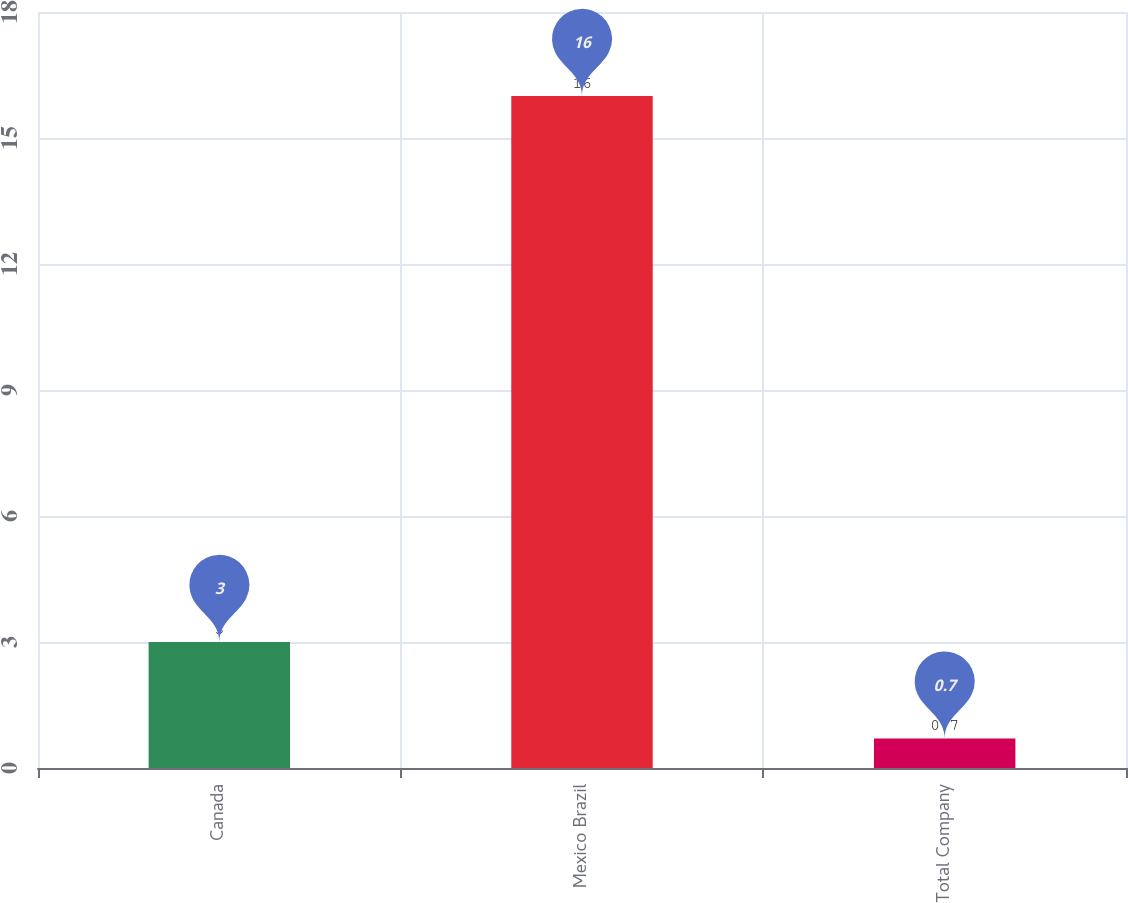<chart> <loc_0><loc_0><loc_500><loc_500><bar_chart><fcel>Canada<fcel>Mexico Brazil<fcel>Total Company<nl><fcel>3<fcel>16<fcel>0.7<nl></chart> 